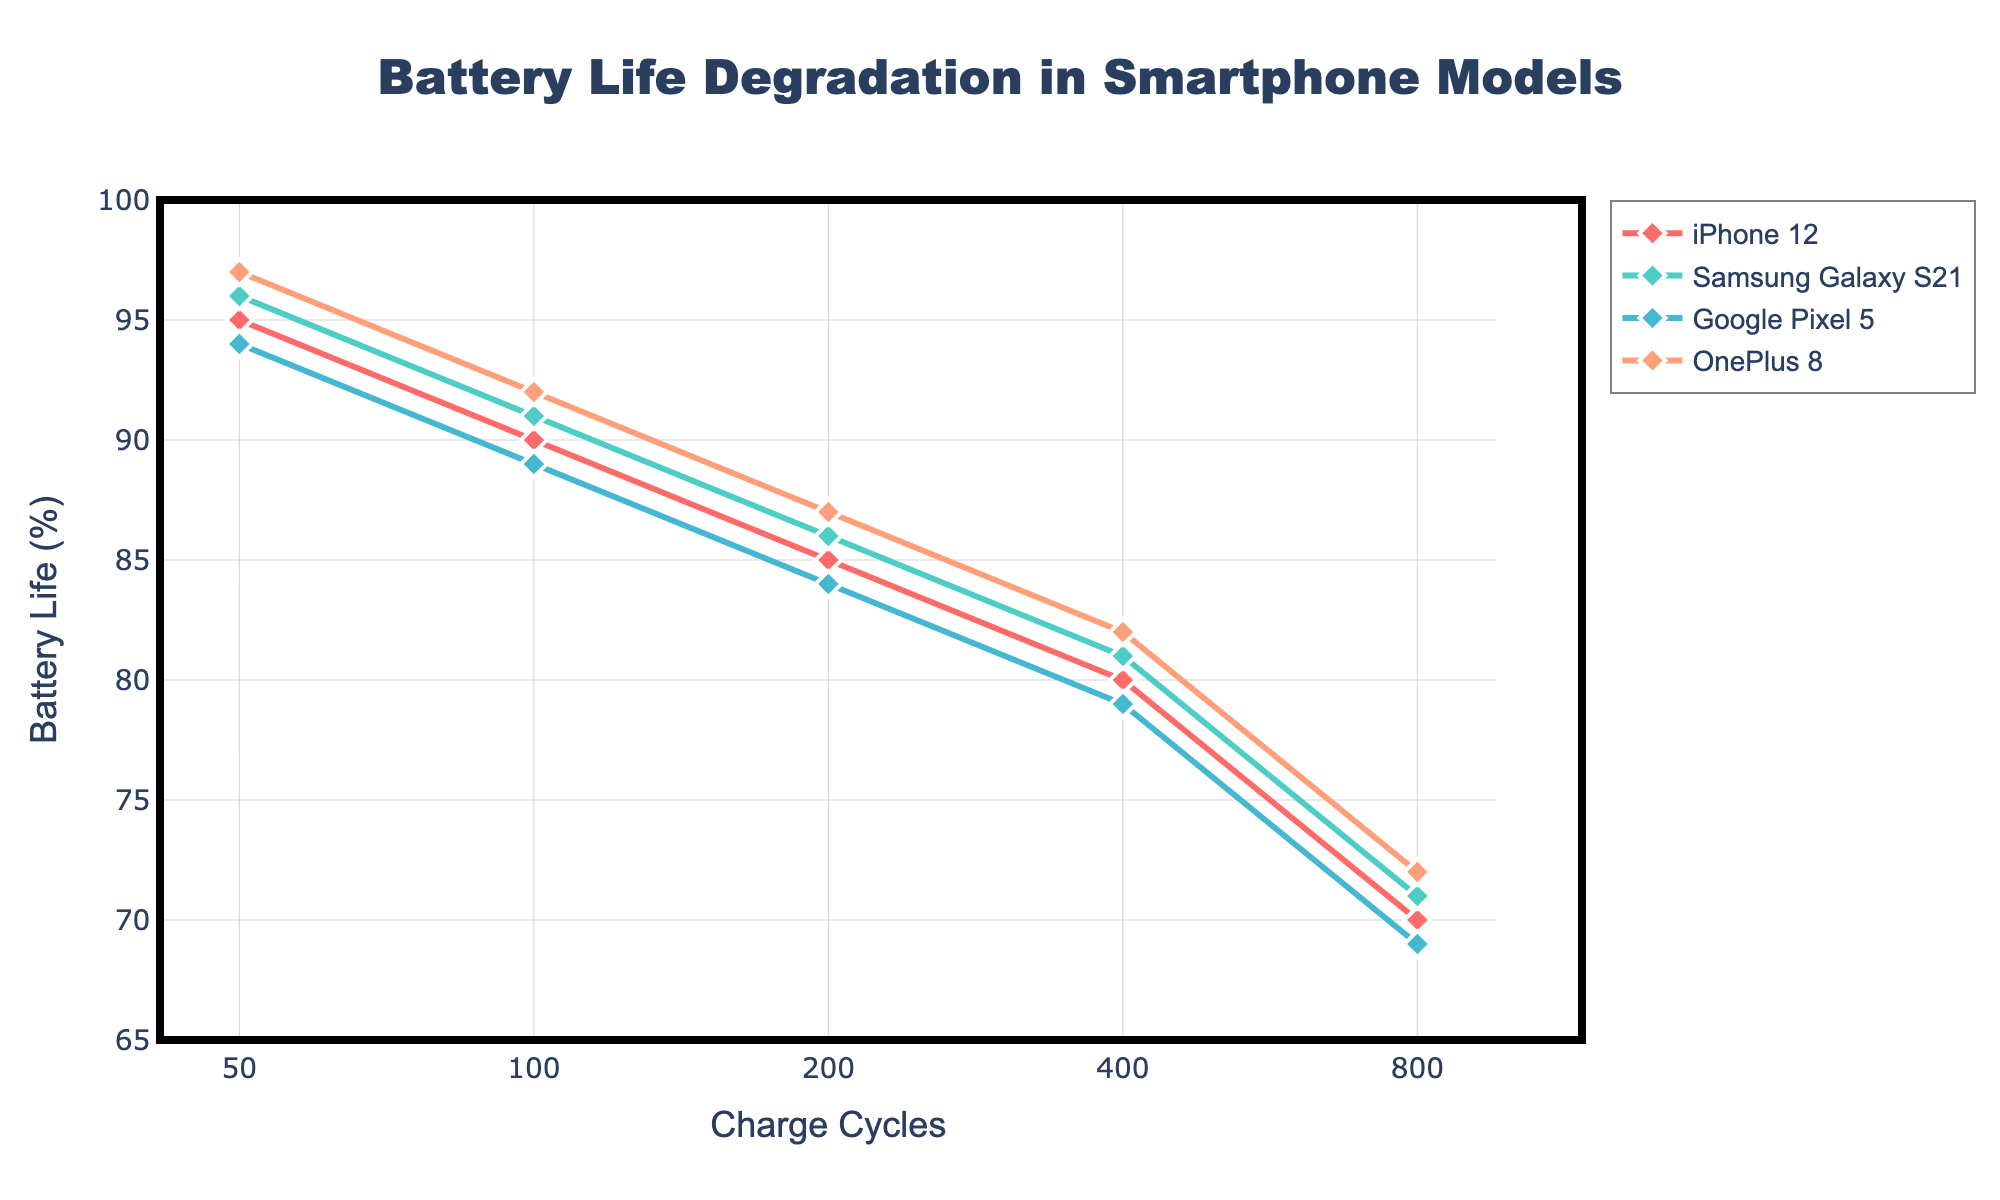What is the title of the plot? The title is located at the top center of the figure in a large, bold font. It summarizes the information presented in the figure.
Answer: Battery Life Degradation in Smartphone Models How many models are compared in the plot? Identify the unique models from the legend, which usually indicates different lines on the plot. There are four differently colored lines, one for each model.
Answer: Four What is the lowest Battery Life percentage reached for the OnePlus 8 model? Locate the line representing OnePlus 8 from the legend, then find the lowest point on this line on the y-axis. The lowest point for OnePlus 8 is at 72% Battery Life.
Answer: 72% Which model has the highest Battery Life at 50 charge cycles? Compare the y-values of different models at the x-axis value of 50 charge cycles. The OnePlus 8 has the highest Battery Life of 97% at 50 charge cycles.
Answer: OnePlus 8 On which axis is the log scale used? The log scale can be identified by the tick marks. Here, the irregular spacing between ticks (50, 100, 200, etc.) on the x-axis indicates a logarithmic scale.
Answer: x-axis What is the average Battery Life percentage at 400 charge cycles for all models? Find the y-value for each model at 400 charge cycles: 80, 81, 79, and 82. Add these values and divide by the number of models (4). (80+81+79+82)/4 = 80.5
Answer: 80.5% Which model shows the most consistent decline in Battery Life across charge cycles? Look for the line that appears the smoothest and most evenly declines. The iPhone 12 line shows a consistent, steady decline across charge cycles.
Answer: iPhone 12 How much more Battery Life does the Samsung Galaxy S21 have compared to Google Pixel 5 at 100 charge cycles? Find and subtract the y-values of the models at 100 charge cycles. Samsung Galaxy S21 is at 91%, and Google Pixel 5 is at 89%. 91% - 89% = 2%
Answer: 2% Which model has the second-lowest Battery Life at 800 charge cycles? Examine the y-values for all models at 800 charge cycles and rank them. The model with the second-lowest value is the Samsung Galaxy S21 at 71%.
Answer: Samsung Galaxy S21 